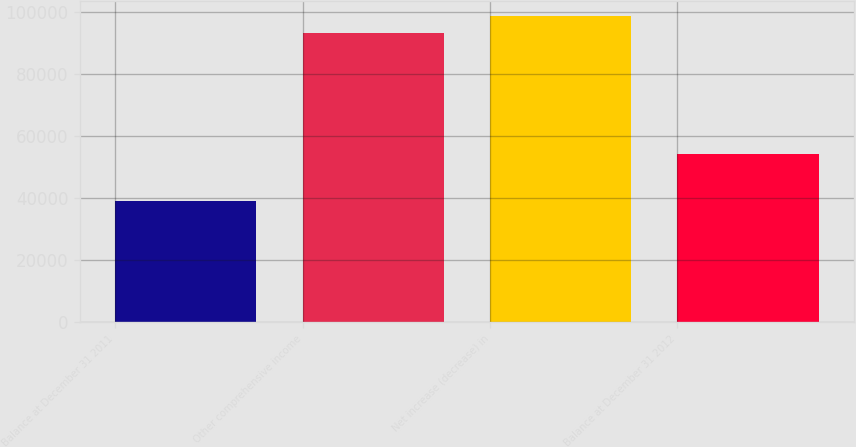<chart> <loc_0><loc_0><loc_500><loc_500><bar_chart><fcel>Balance at December 31 2011<fcel>Other comprehensive income<fcel>Net increase (decrease) in<fcel>Balance at December 31 2012<nl><fcel>39078<fcel>93380<fcel>98810.2<fcel>54302<nl></chart> 